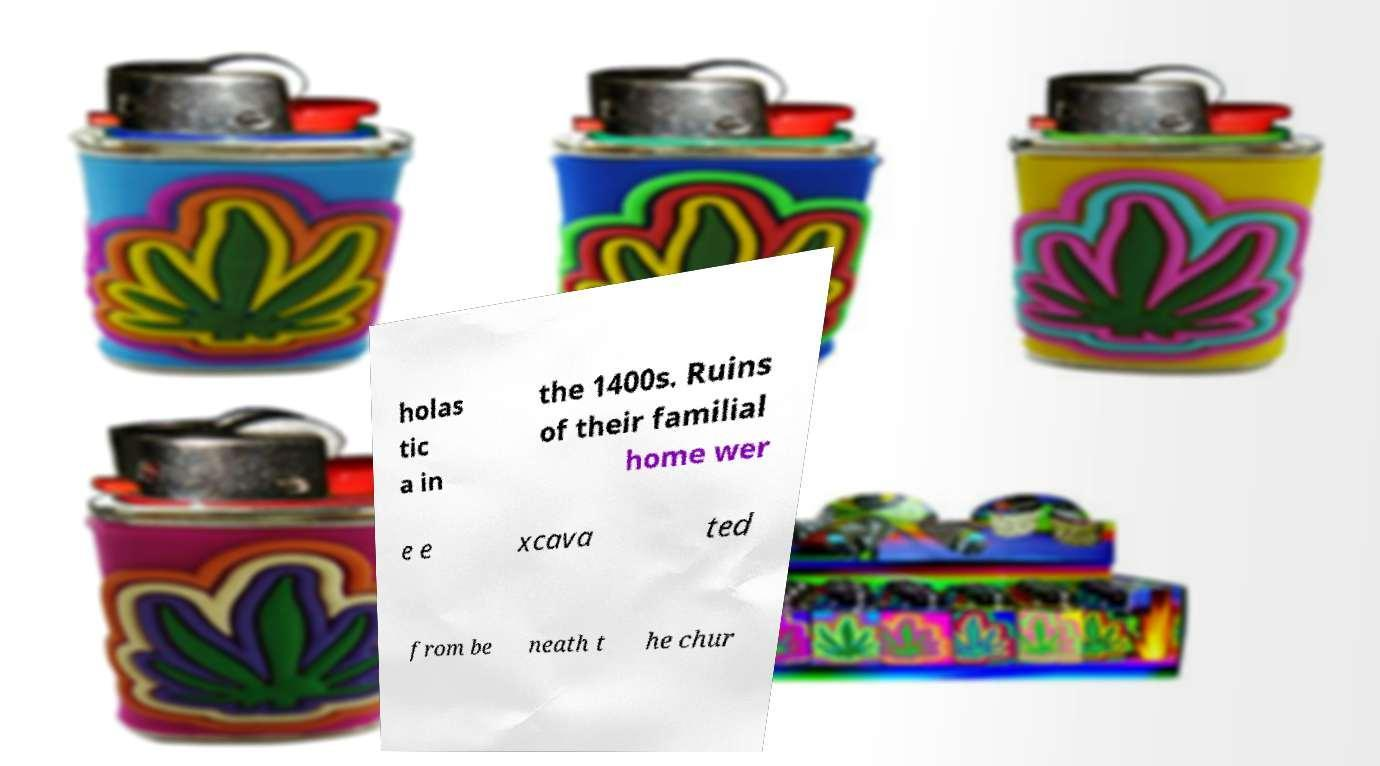Can you read and provide the text displayed in the image?This photo seems to have some interesting text. Can you extract and type it out for me? holas tic a in the 1400s. Ruins of their familial home wer e e xcava ted from be neath t he chur 